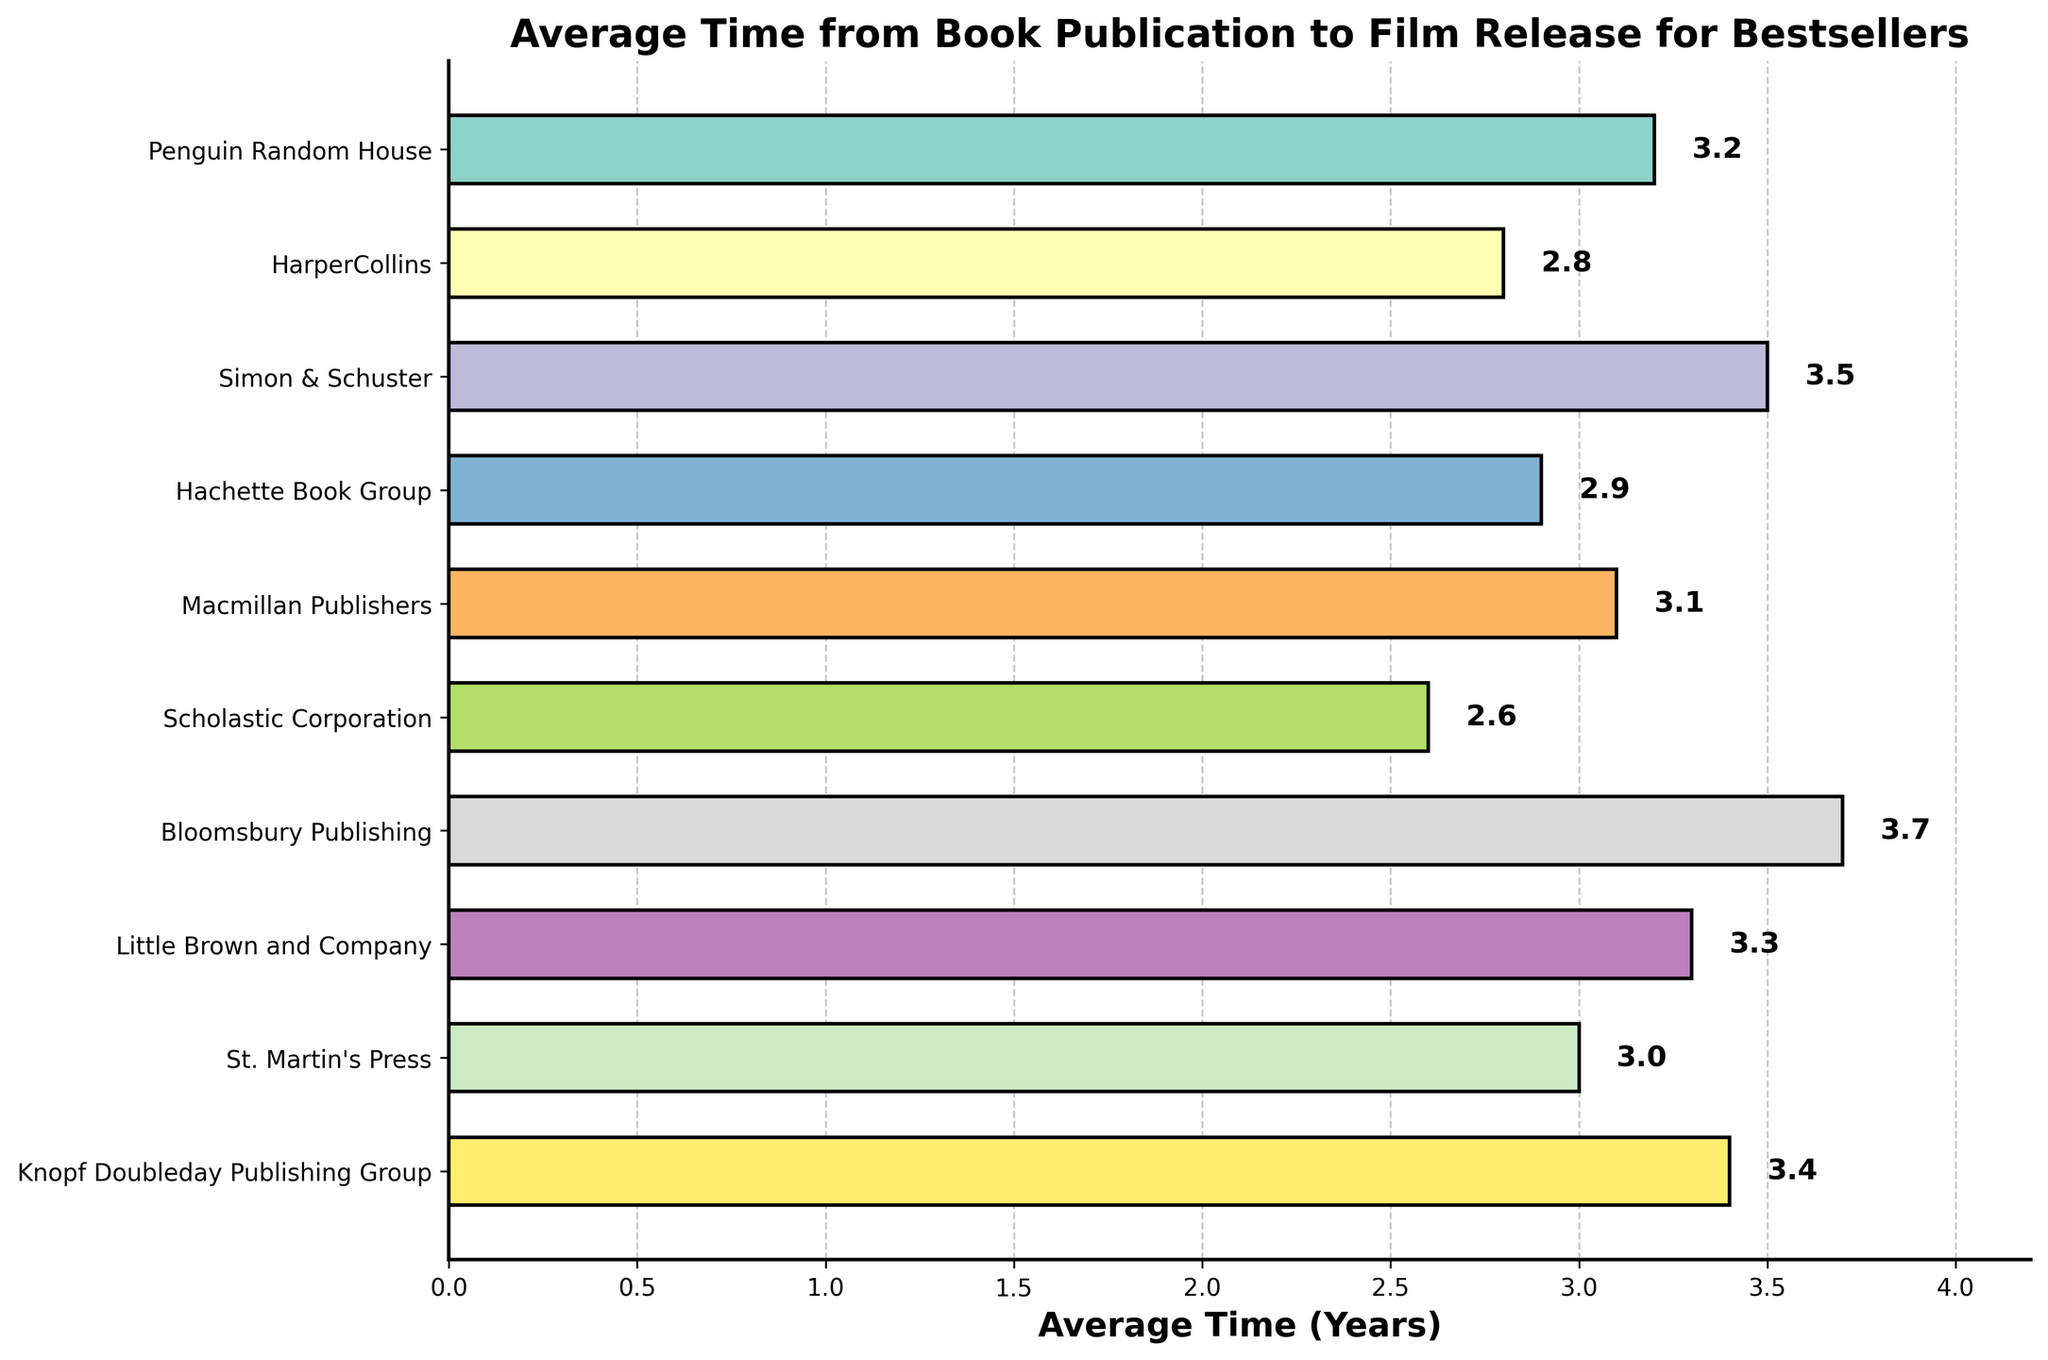What is the title of the plot? The title is generally found at the top of the plot and gives a summary of the information presented. The title in this case is: 'Average Time from Book Publication to Film Release for Bestsellers'.
Answer: Average Time from Book Publication to Film Release for Bestsellers What is the average time from book publication to film release for Penguin Random House? This value is shown on the bar corresponding to Penguin Random House, found on the y-axis. The label on the end of the bar indicates the specific value.
Answer: 3.2 years How many publishing houses have an average time greater than 3 years? Count the number of bars that extend beyond the 3-year mark on the x-axis. The labels at the end of each bar make it easier to determine which ones qualify.
Answer: 6 Which publishing house has the shortest average time from book publication to film release? Look for the bar with the smallest length on the x-axis. The label at the end of this bar indicates the specific value.
Answer: Scholastic Corporation Is the average time for Little Brown and Company greater or less than that of HarperCollins? Compare the lengths of the bars for Little Brown and Company and HarperCollins against each other. The labels on the bars and their respective positions along the x-axis indicate the difference.
Answer: Greater What is the color scheme used in the plot? Identify the color pattern used for the bars. This particular plot uses a diversified color palette for differentiation. The colors are sourced from a color map known as 'Set3'.
Answer: Set3 colormap How does the average time for Macmillan Publishers compare to that of St. Martin's Press? Compare the lengths of the bars for Macmillan Publishers and St. Martin's Press directly. The labels on the bars help in determining the specific differences.
Answer: Slightly greater What is the total number of publishing houses listed in the plot? Count the number of bars presented in the plot, each bar representing a different publishing house listed on the y-axis.
Answer: 10 What is the difference in average time between the Publishing House with the longest and shortest average times? Subtract the shortest average time from the longest one. The longest time is 3.7 years (Bloomsbury Publishing) and the shortest time is 2.6 years (Scholastic Corporation).
Answer: 1.1 years What is the grid style used in the plot? The visual grid helps to align the values on the x-axis. The gridlines in this plot are dashed lines with a particular degree of transparency (alpha=0.7).
Answer: Dashed lines with alpha 0.7 